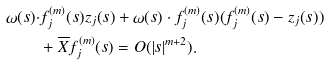Convert formula to latex. <formula><loc_0><loc_0><loc_500><loc_500>\omega ( s ) \cdot & f _ { j } ^ { ( m ) } ( s ) z _ { j } ( s ) + \omega ( s ) \cdot f _ { j } ^ { ( m ) } ( s ) ( f _ { j } ^ { ( m ) } ( s ) - z _ { j } ( s ) ) \\ & + { \overline { X } } f _ { j } ^ { ( m ) } ( s ) = O ( | s | ^ { m + 2 } ) .</formula> 